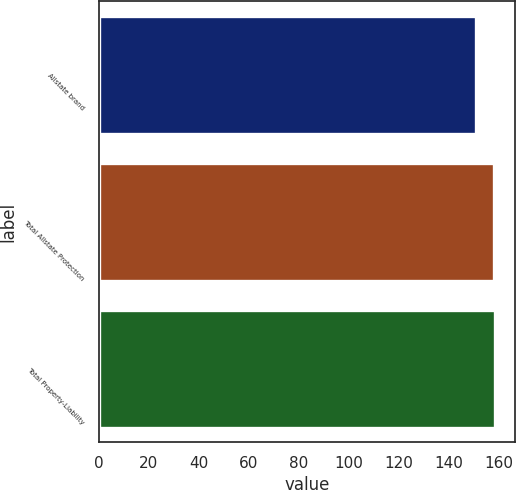<chart> <loc_0><loc_0><loc_500><loc_500><bar_chart><fcel>Allstate brand<fcel>Total Allstate Protection<fcel>Total Property-Liability<nl><fcel>151<fcel>158<fcel>158.7<nl></chart> 